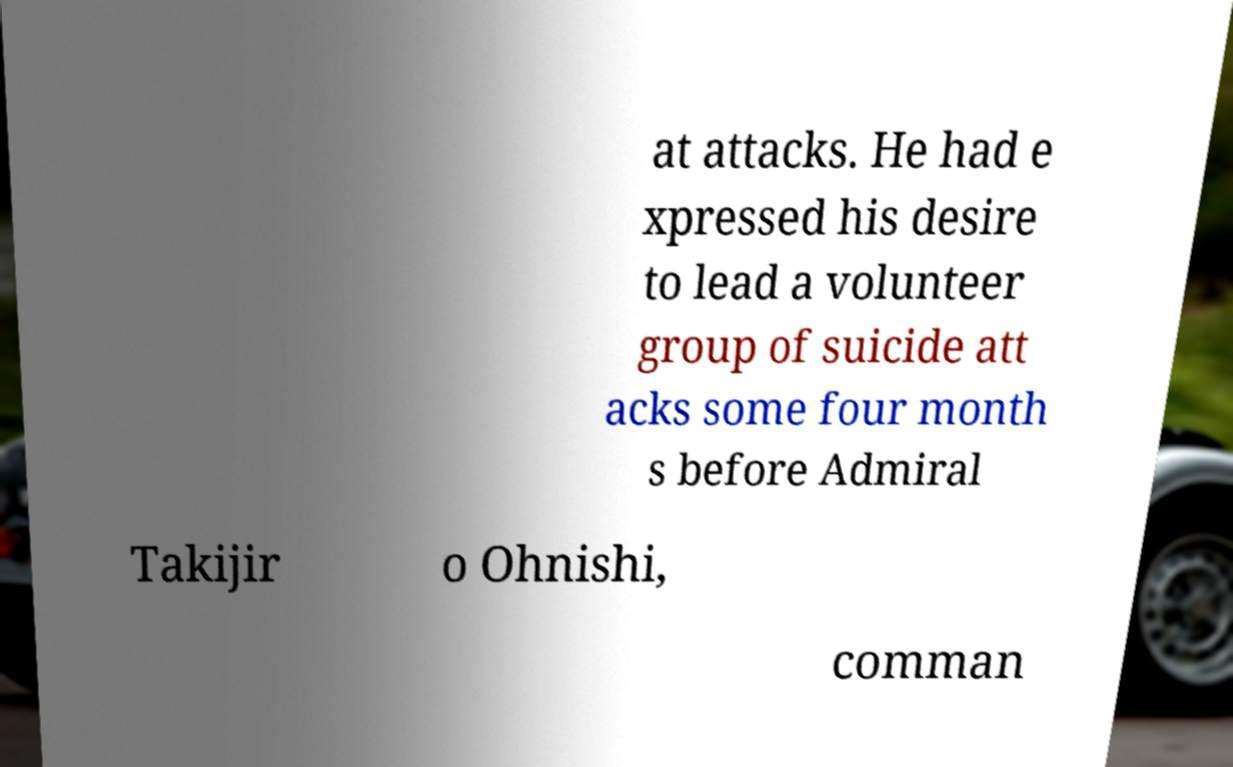For documentation purposes, I need the text within this image transcribed. Could you provide that? at attacks. He had e xpressed his desire to lead a volunteer group of suicide att acks some four month s before Admiral Takijir o Ohnishi, comman 